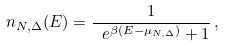<formula> <loc_0><loc_0><loc_500><loc_500>n _ { N , \Delta } ( E ) = \frac { 1 } { \ e ^ { \beta ( E - \mu _ { N , \Delta } ) } + 1 } \, ,</formula> 